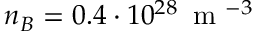Convert formula to latex. <formula><loc_0><loc_0><loc_500><loc_500>n _ { B } = 0 . 4 \cdot 1 0 ^ { 2 8 } \, m ^ { - 3 }</formula> 